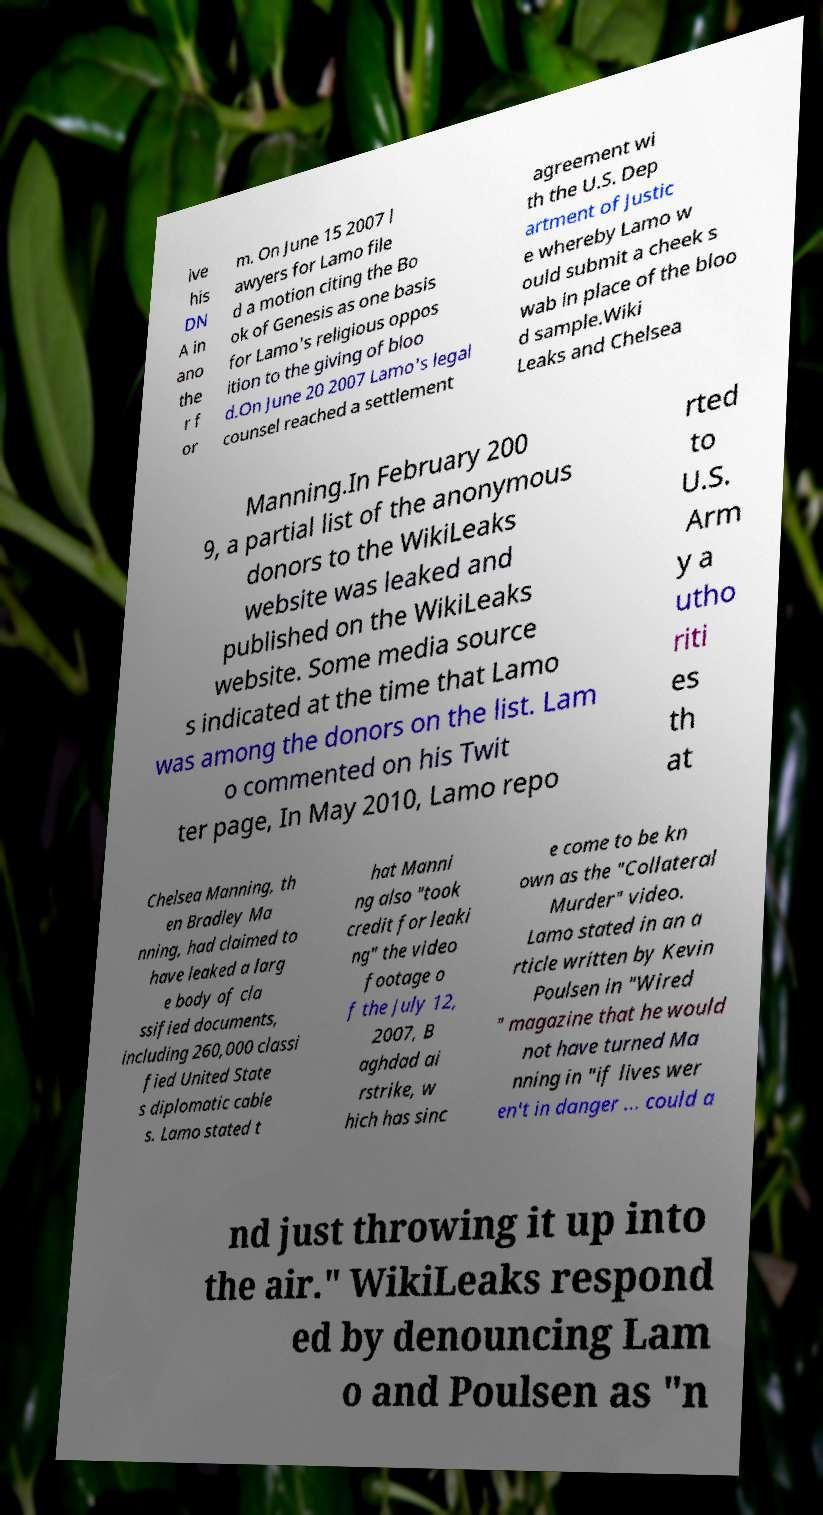Please identify and transcribe the text found in this image. ive his DN A in ano the r f or m. On June 15 2007 l awyers for Lamo file d a motion citing the Bo ok of Genesis as one basis for Lamo's religious oppos ition to the giving of bloo d.On June 20 2007 Lamo's legal counsel reached a settlement agreement wi th the U.S. Dep artment of Justic e whereby Lamo w ould submit a cheek s wab in place of the bloo d sample.Wiki Leaks and Chelsea Manning.In February 200 9, a partial list of the anonymous donors to the WikiLeaks website was leaked and published on the WikiLeaks website. Some media source s indicated at the time that Lamo was among the donors on the list. Lam o commented on his Twit ter page, In May 2010, Lamo repo rted to U.S. Arm y a utho riti es th at Chelsea Manning, th en Bradley Ma nning, had claimed to have leaked a larg e body of cla ssified documents, including 260,000 classi fied United State s diplomatic cable s. Lamo stated t hat Manni ng also "took credit for leaki ng" the video footage o f the July 12, 2007, B aghdad ai rstrike, w hich has sinc e come to be kn own as the "Collateral Murder" video. Lamo stated in an a rticle written by Kevin Poulsen in "Wired " magazine that he would not have turned Ma nning in "if lives wer en't in danger ... could a nd just throwing it up into the air." WikiLeaks respond ed by denouncing Lam o and Poulsen as "n 